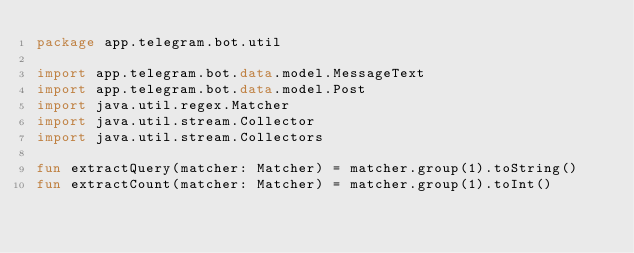Convert code to text. <code><loc_0><loc_0><loc_500><loc_500><_Kotlin_>package app.telegram.bot.util

import app.telegram.bot.data.model.MessageText
import app.telegram.bot.data.model.Post
import java.util.regex.Matcher
import java.util.stream.Collector
import java.util.stream.Collectors

fun extractQuery(matcher: Matcher) = matcher.group(1).toString()
fun extractCount(matcher: Matcher) = matcher.group(1).toInt()
</code> 